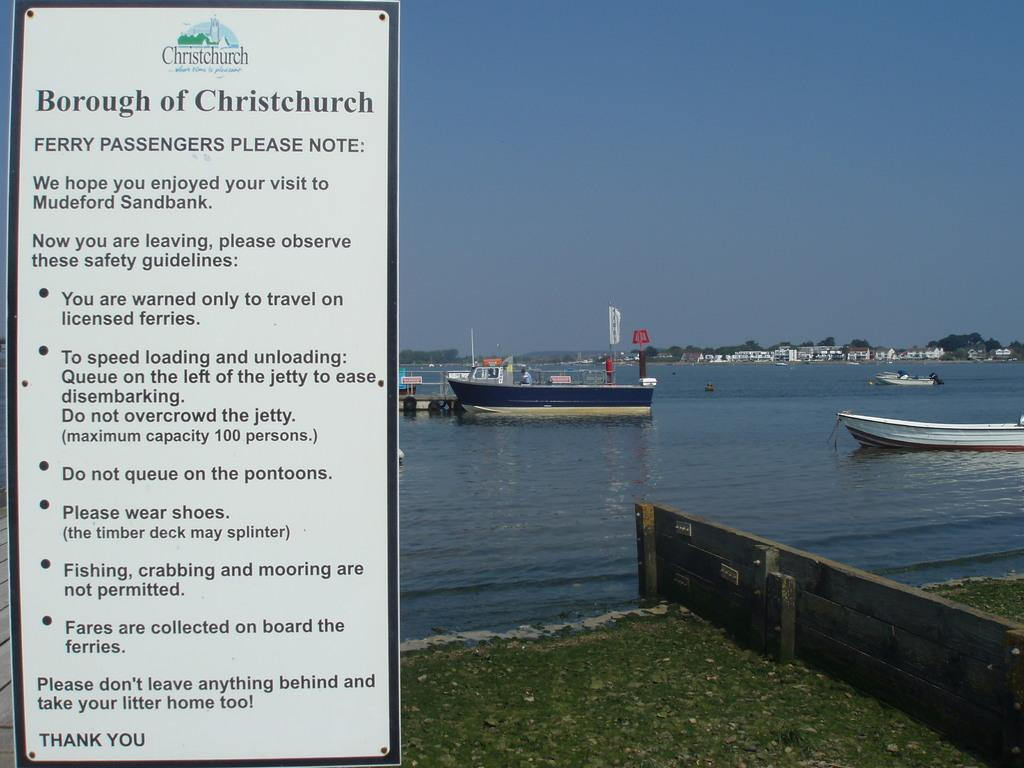What is on the left side of the image? There is a board with writing on the left side of the image. What can be seen in the water in the image? There are boats in the water. What type of structure is on the right side of the image? There is a wooden wall on the right side of the image. What is visible in the background of the image? The sky is visible in the background of the image. Can you see a drum floating in the water in the image? There is no drum visible in the water in the image. How many dimes are scattered on the wooden wall in the image? There are no dimes present in the image. 